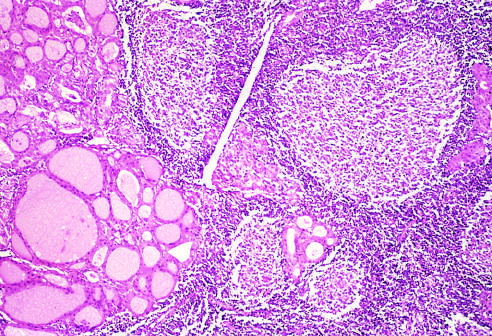what are seen?
Answer the question using a single word or phrase. Residual thyroid follicles lined by deeply eosinophilic hurthle cells 